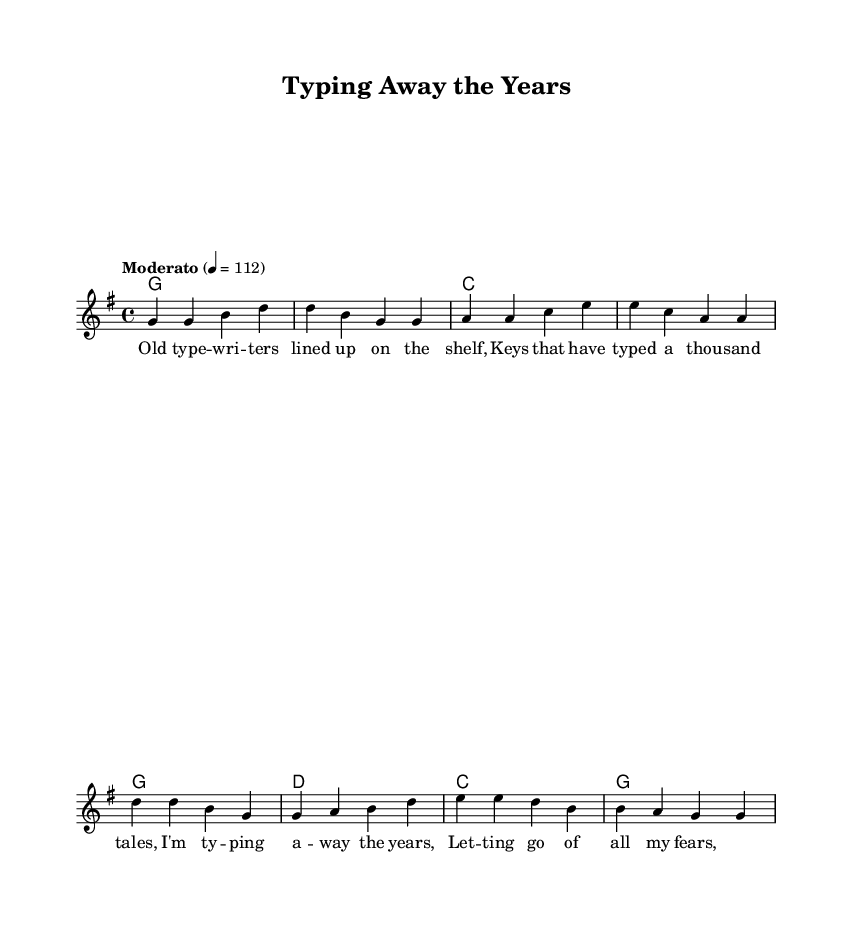What is the key signature of this music? The key signature of the music is G major, which has one sharp (F#). This can be identified in the global settings of the code where it states \key g \major.
Answer: G major What is the time signature of this music? The time signature is 4/4, indicating that there are four beats in each measure, which is specified in the global settings with \time 4/4.
Answer: 4/4 What is the tempo marking indicated in the music? The tempo marking of the piece is "Moderato," and it indicates a moderate speed, set at 112 beats per minute in the global section labeled \tempo "Moderato" 4 = 112.
Answer: Moderato How many measures are in the verse section? By counting the groupings in the melody section, there are a total of 4 measures in the verse. The verse is denoted by distinct sections in the melody.
Answer: 4 What is the tonic chord for the harmony in the verse? The tonic chord for the harmony in the verse is G major. This can be determined by looking at the first chord in the \harmonies section, which starts with g1, indicating the G major chord.
Answer: G Which lyrical theme is expressed in the chorus? The chorus expresses themes of letting go of fears and reflecting on the passage of time, as indicated by the lyrics “I'm typing away the years, letting go of all my fears.” These themes are typical in country rock songs about moving on.
Answer: Letting go of fears Which section comes first, the verse or the chorus? The verse section comes first, as it is defined before the chorus in the structure of the song's melody and lyrical arrangement. The first segment contains the lyrics associated with the verse.
Answer: Verse 